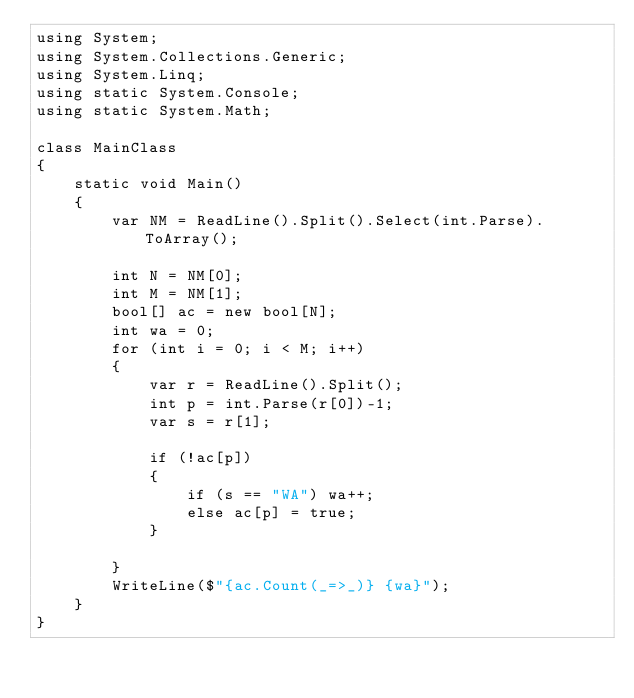Convert code to text. <code><loc_0><loc_0><loc_500><loc_500><_C#_>using System;
using System.Collections.Generic;
using System.Linq;
using static System.Console;
using static System.Math;

class MainClass
{
    static void Main()
    {
        var NM = ReadLine().Split().Select(int.Parse).ToArray();

        int N = NM[0];
        int M = NM[1];
        bool[] ac = new bool[N];
        int wa = 0;
        for (int i = 0; i < M; i++)
        {
            var r = ReadLine().Split();
            int p = int.Parse(r[0])-1;
            var s = r[1];

            if (!ac[p])
            {
                if (s == "WA") wa++;
                else ac[p] = true;
            }

        }
        WriteLine($"{ac.Count(_=>_)} {wa}");
    }
}
</code> 